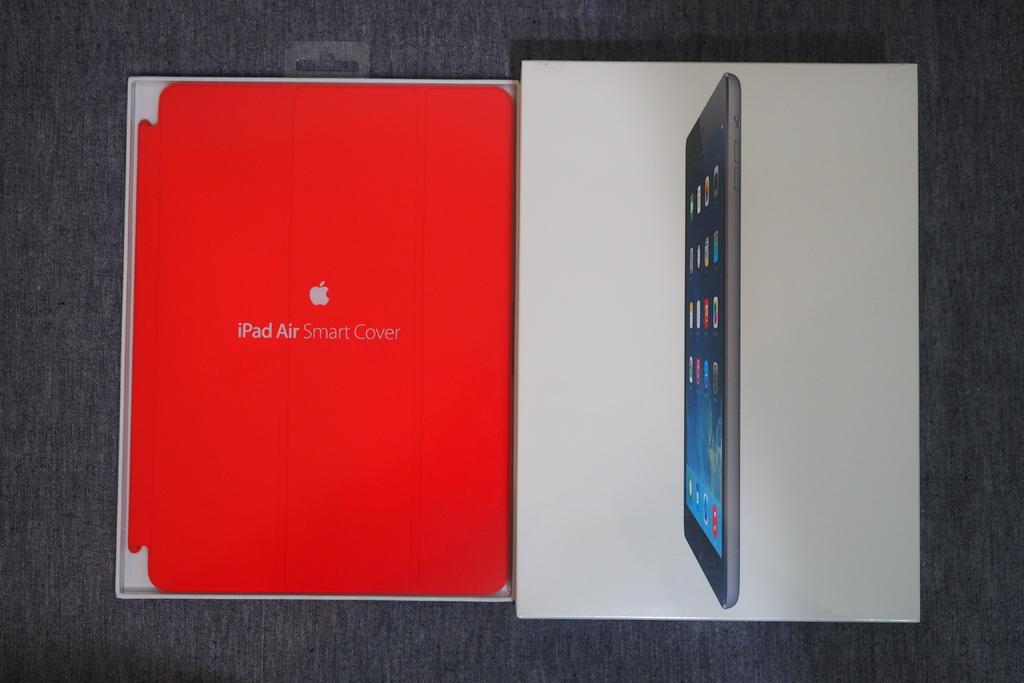<image>
Write a terse but informative summary of the picture. an ipad air smart cover case next to an ipad box 